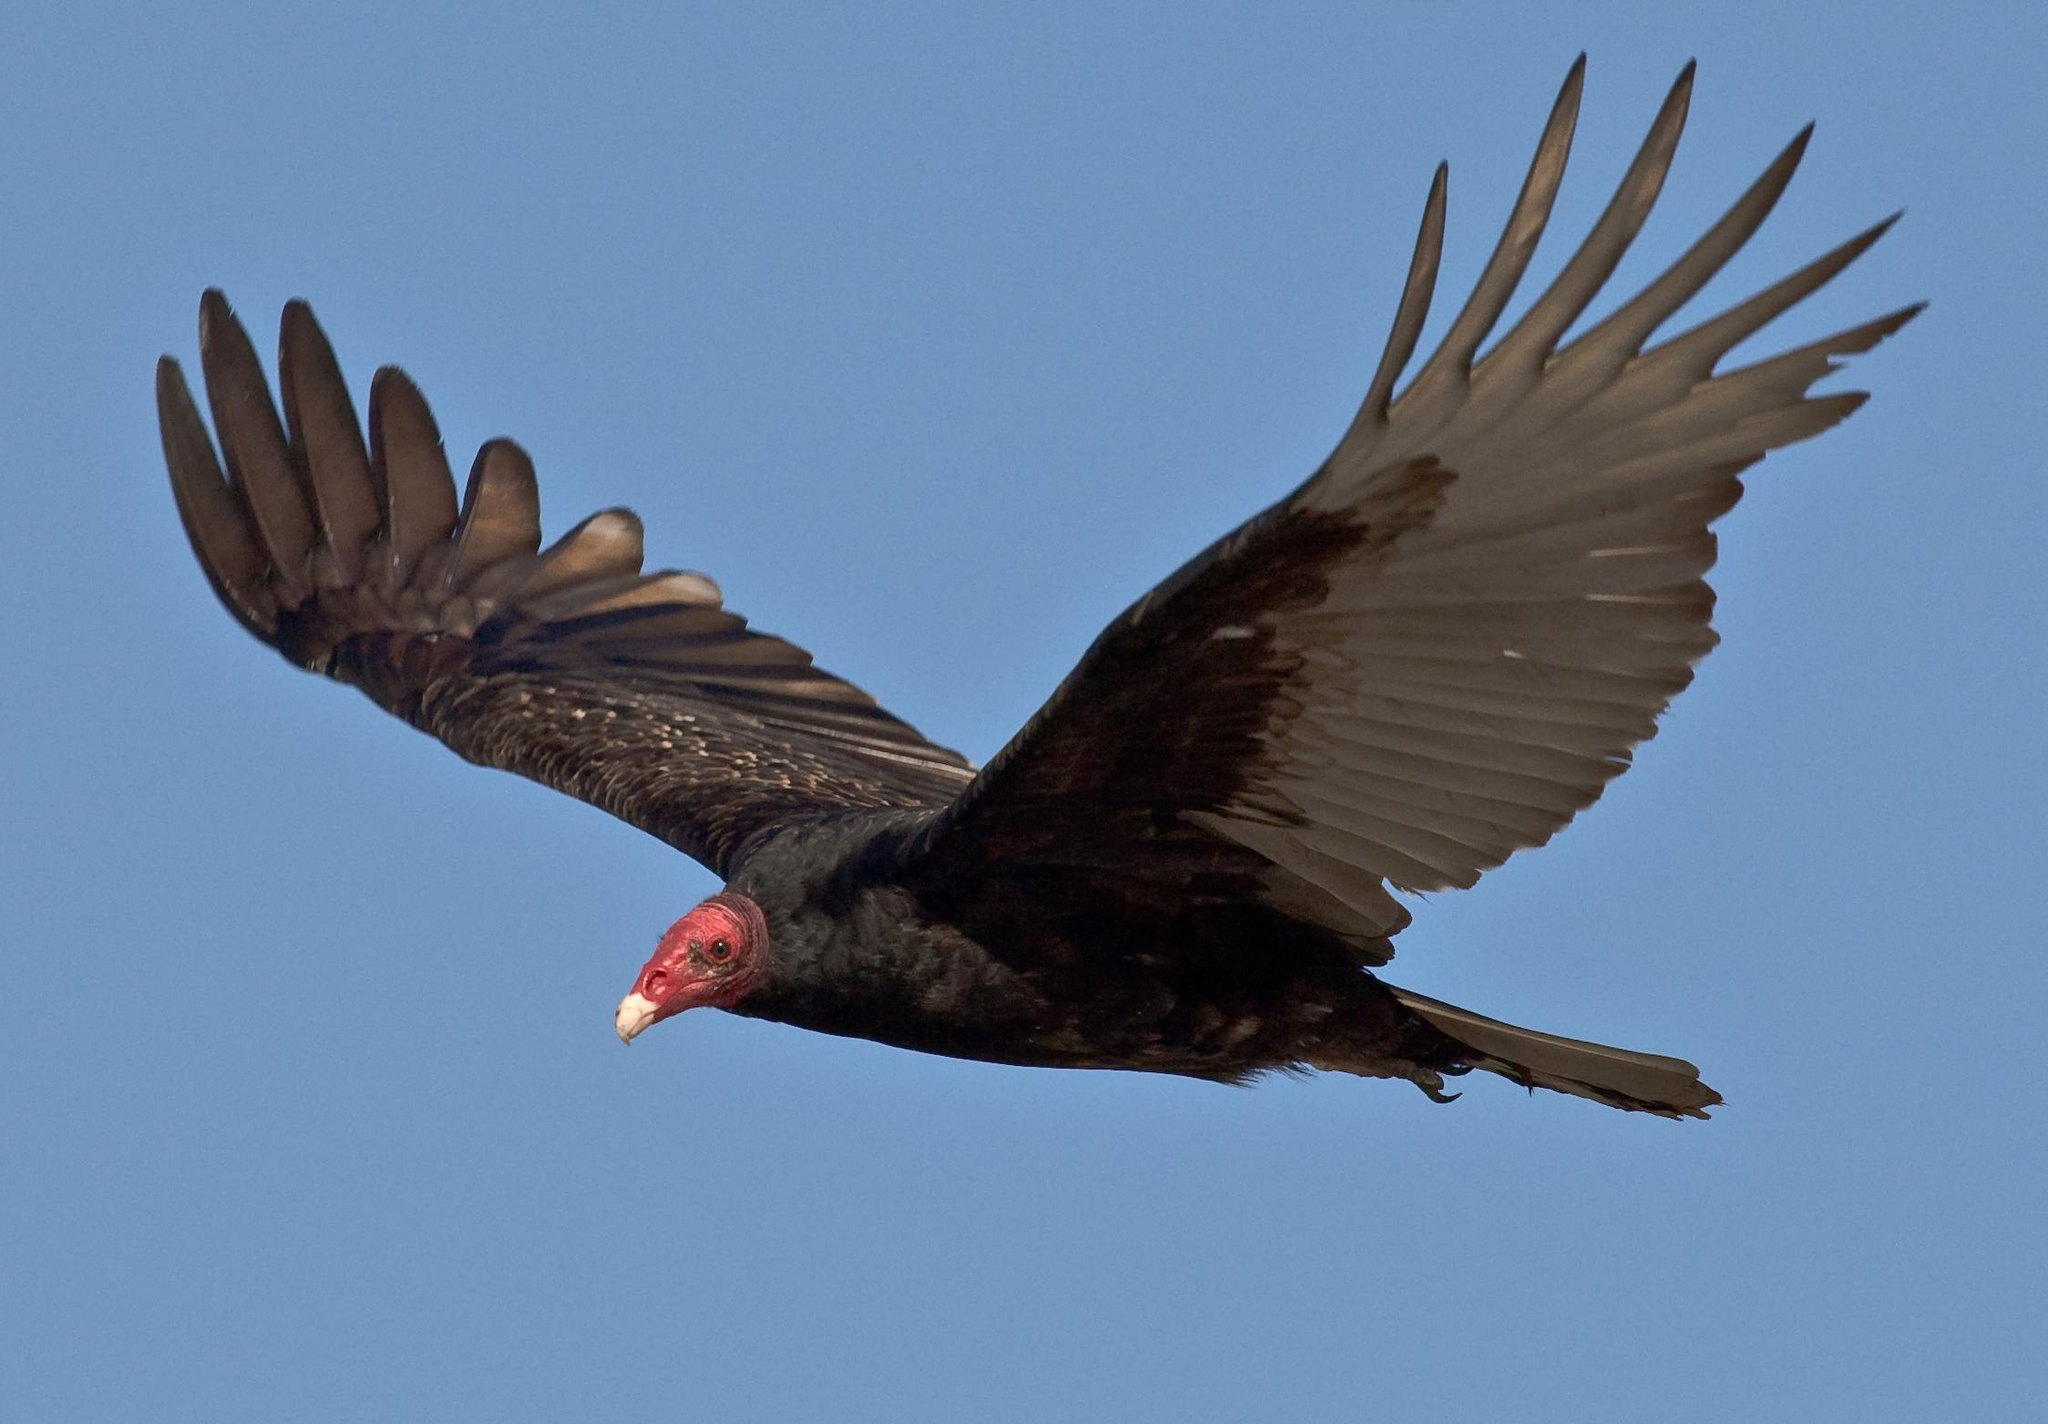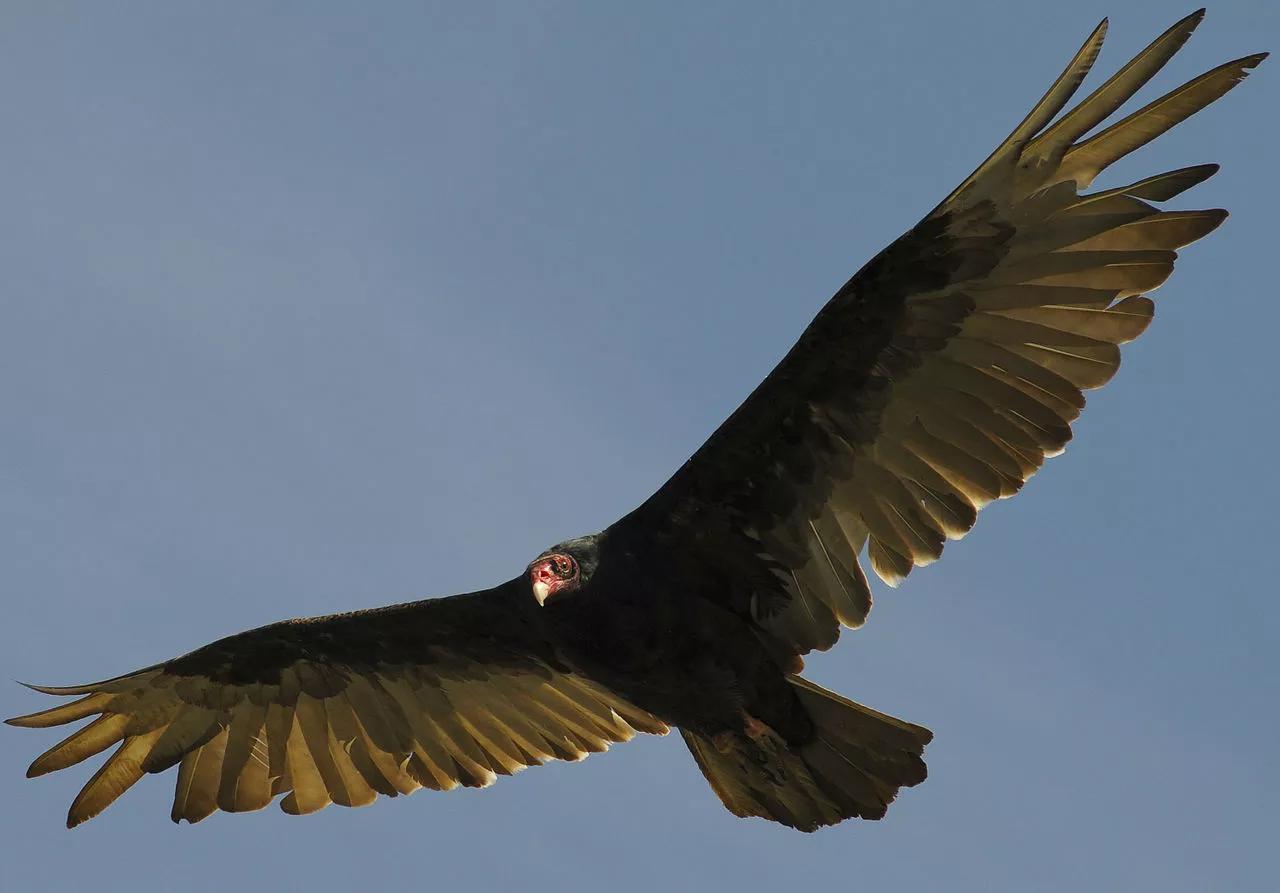The first image is the image on the left, the second image is the image on the right. Examine the images to the left and right. Is the description "There are two vultures flying" accurate? Answer yes or no. Yes. 